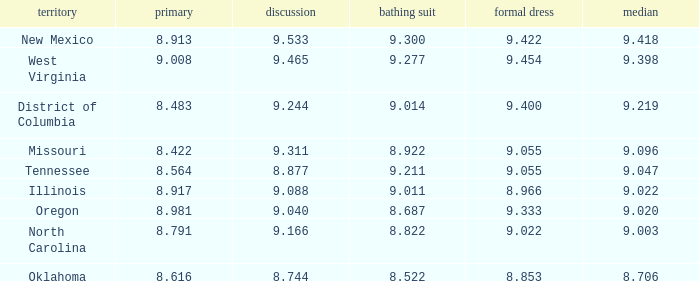Can you give me this table as a dict? {'header': ['territory', 'primary', 'discussion', 'bathing suit', 'formal dress', 'median'], 'rows': [['New Mexico', '8.913', '9.533', '9.300', '9.422', '9.418'], ['West Virginia', '9.008', '9.465', '9.277', '9.454', '9.398'], ['District of Columbia', '8.483', '9.244', '9.014', '9.400', '9.219'], ['Missouri', '8.422', '9.311', '8.922', '9.055', '9.096'], ['Tennessee', '8.564', '8.877', '9.211', '9.055', '9.047'], ['Illinois', '8.917', '9.088', '9.011', '8.966', '9.022'], ['Oregon', '8.981', '9.040', '8.687', '9.333', '9.020'], ['North Carolina', '8.791', '9.166', '8.822', '9.022', '9.003'], ['Oklahoma', '8.616', '8.744', '8.522', '8.853', '8.706']]} Name the swuinsuit for oregon 8.687. 